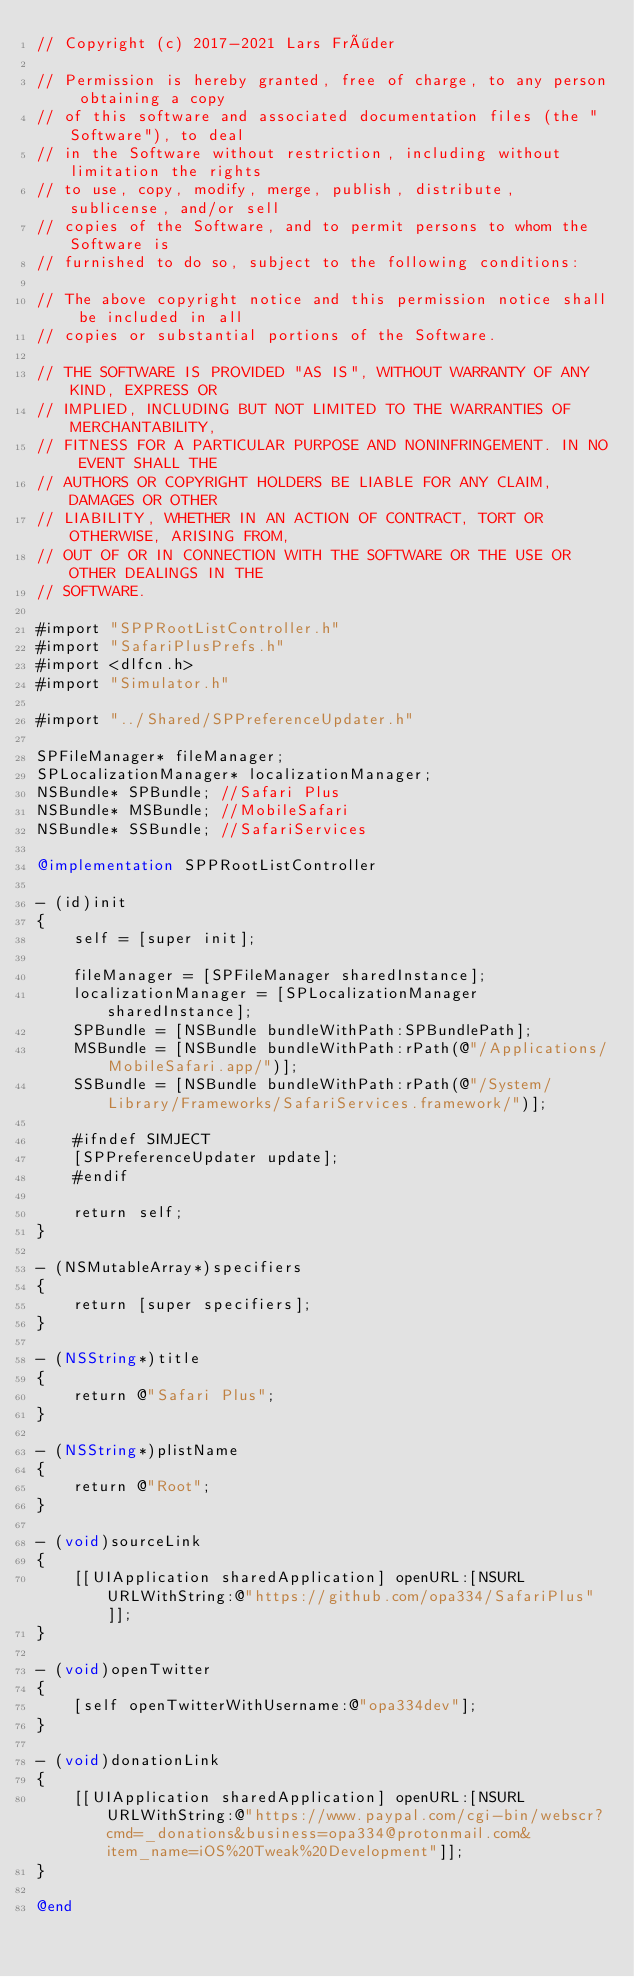Convert code to text. <code><loc_0><loc_0><loc_500><loc_500><_ObjectiveC_>// Copyright (c) 2017-2021 Lars Fröder

// Permission is hereby granted, free of charge, to any person obtaining a copy
// of this software and associated documentation files (the "Software"), to deal
// in the Software without restriction, including without limitation the rights
// to use, copy, modify, merge, publish, distribute, sublicense, and/or sell
// copies of the Software, and to permit persons to whom the Software is
// furnished to do so, subject to the following conditions:

// The above copyright notice and this permission notice shall be included in all
// copies or substantial portions of the Software.

// THE SOFTWARE IS PROVIDED "AS IS", WITHOUT WARRANTY OF ANY KIND, EXPRESS OR
// IMPLIED, INCLUDING BUT NOT LIMITED TO THE WARRANTIES OF MERCHANTABILITY,
// FITNESS FOR A PARTICULAR PURPOSE AND NONINFRINGEMENT. IN NO EVENT SHALL THE
// AUTHORS OR COPYRIGHT HOLDERS BE LIABLE FOR ANY CLAIM, DAMAGES OR OTHER
// LIABILITY, WHETHER IN AN ACTION OF CONTRACT, TORT OR OTHERWISE, ARISING FROM,
// OUT OF OR IN CONNECTION WITH THE SOFTWARE OR THE USE OR OTHER DEALINGS IN THE
// SOFTWARE.

#import "SPPRootListController.h"
#import "SafariPlusPrefs.h"
#import <dlfcn.h>
#import "Simulator.h"

#import "../Shared/SPPreferenceUpdater.h"

SPFileManager* fileManager;
SPLocalizationManager* localizationManager;
NSBundle* SPBundle;	//Safari Plus
NSBundle* MSBundle;	//MobileSafari
NSBundle* SSBundle;	//SafariServices

@implementation SPPRootListController

- (id)init
{
	self = [super init];

	fileManager = [SPFileManager sharedInstance];
	localizationManager = [SPLocalizationManager sharedInstance];
	SPBundle = [NSBundle bundleWithPath:SPBundlePath];
	MSBundle = [NSBundle bundleWithPath:rPath(@"/Applications/MobileSafari.app/")];
	SSBundle = [NSBundle bundleWithPath:rPath(@"/System/Library/Frameworks/SafariServices.framework/")];

	#ifndef SIMJECT
	[SPPreferenceUpdater update];
	#endif

	return self;
}

- (NSMutableArray*)specifiers
{
	return [super specifiers];
}

- (NSString*)title
{
	return @"Safari Plus";
}

- (NSString*)plistName
{
	return @"Root";
}

- (void)sourceLink
{
	[[UIApplication sharedApplication] openURL:[NSURL URLWithString:@"https://github.com/opa334/SafariPlus"]];
}

- (void)openTwitter
{
	[self openTwitterWithUsername:@"opa334dev"];
}

- (void)donationLink
{
	[[UIApplication sharedApplication] openURL:[NSURL URLWithString:@"https://www.paypal.com/cgi-bin/webscr?cmd=_donations&business=opa334@protonmail.com&item_name=iOS%20Tweak%20Development"]];
}

@end
</code> 